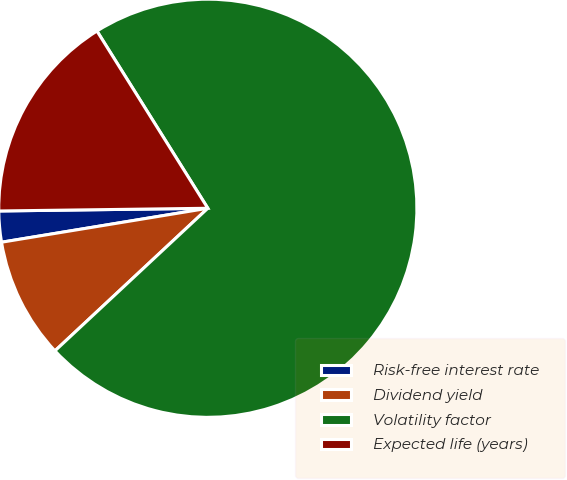Convert chart. <chart><loc_0><loc_0><loc_500><loc_500><pie_chart><fcel>Risk-free interest rate<fcel>Dividend yield<fcel>Volatility factor<fcel>Expected life (years)<nl><fcel>2.39%<fcel>9.35%<fcel>71.95%<fcel>16.31%<nl></chart> 